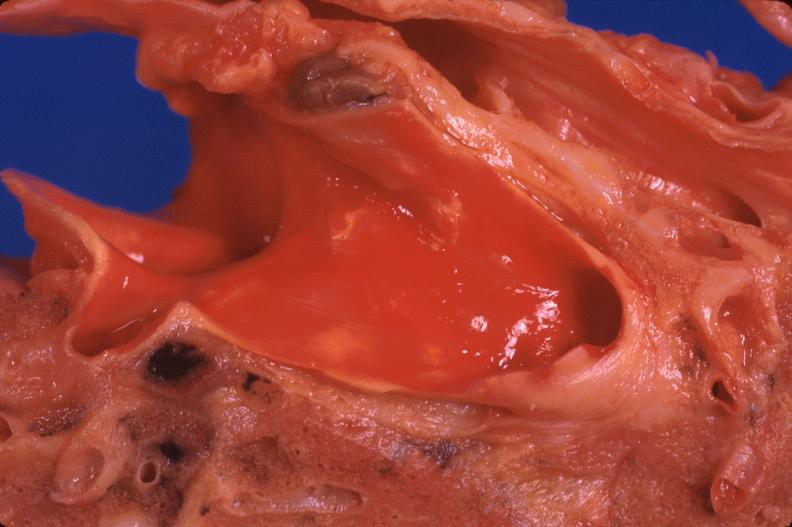what does this image show?
Answer the question using a single word or phrase. Lung 